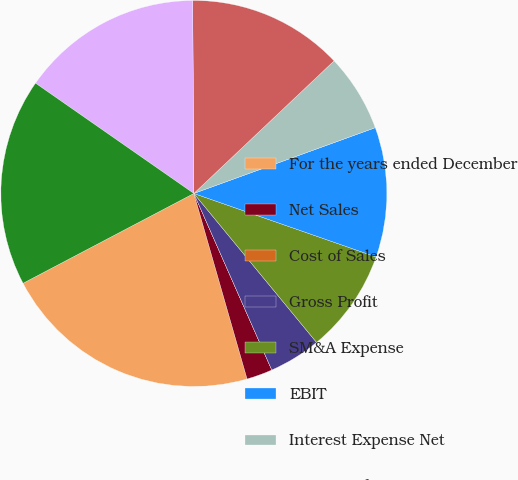Convert chart to OTSL. <chart><loc_0><loc_0><loc_500><loc_500><pie_chart><fcel>For the years ended December<fcel>Net Sales<fcel>Cost of Sales<fcel>Gross Profit<fcel>SM&A Expense<fcel>EBIT<fcel>Interest Expense Net<fcel>Provision for Income Taxes<fcel>Net Income<fcel>Net Income Per Share-Diluted<nl><fcel>21.74%<fcel>2.17%<fcel>0.0%<fcel>4.35%<fcel>8.7%<fcel>10.87%<fcel>6.52%<fcel>13.04%<fcel>15.22%<fcel>17.39%<nl></chart> 